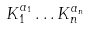Convert formula to latex. <formula><loc_0><loc_0><loc_500><loc_500>K _ { 1 } ^ { a _ { 1 } } \dots K _ { n } ^ { a _ { n } }</formula> 